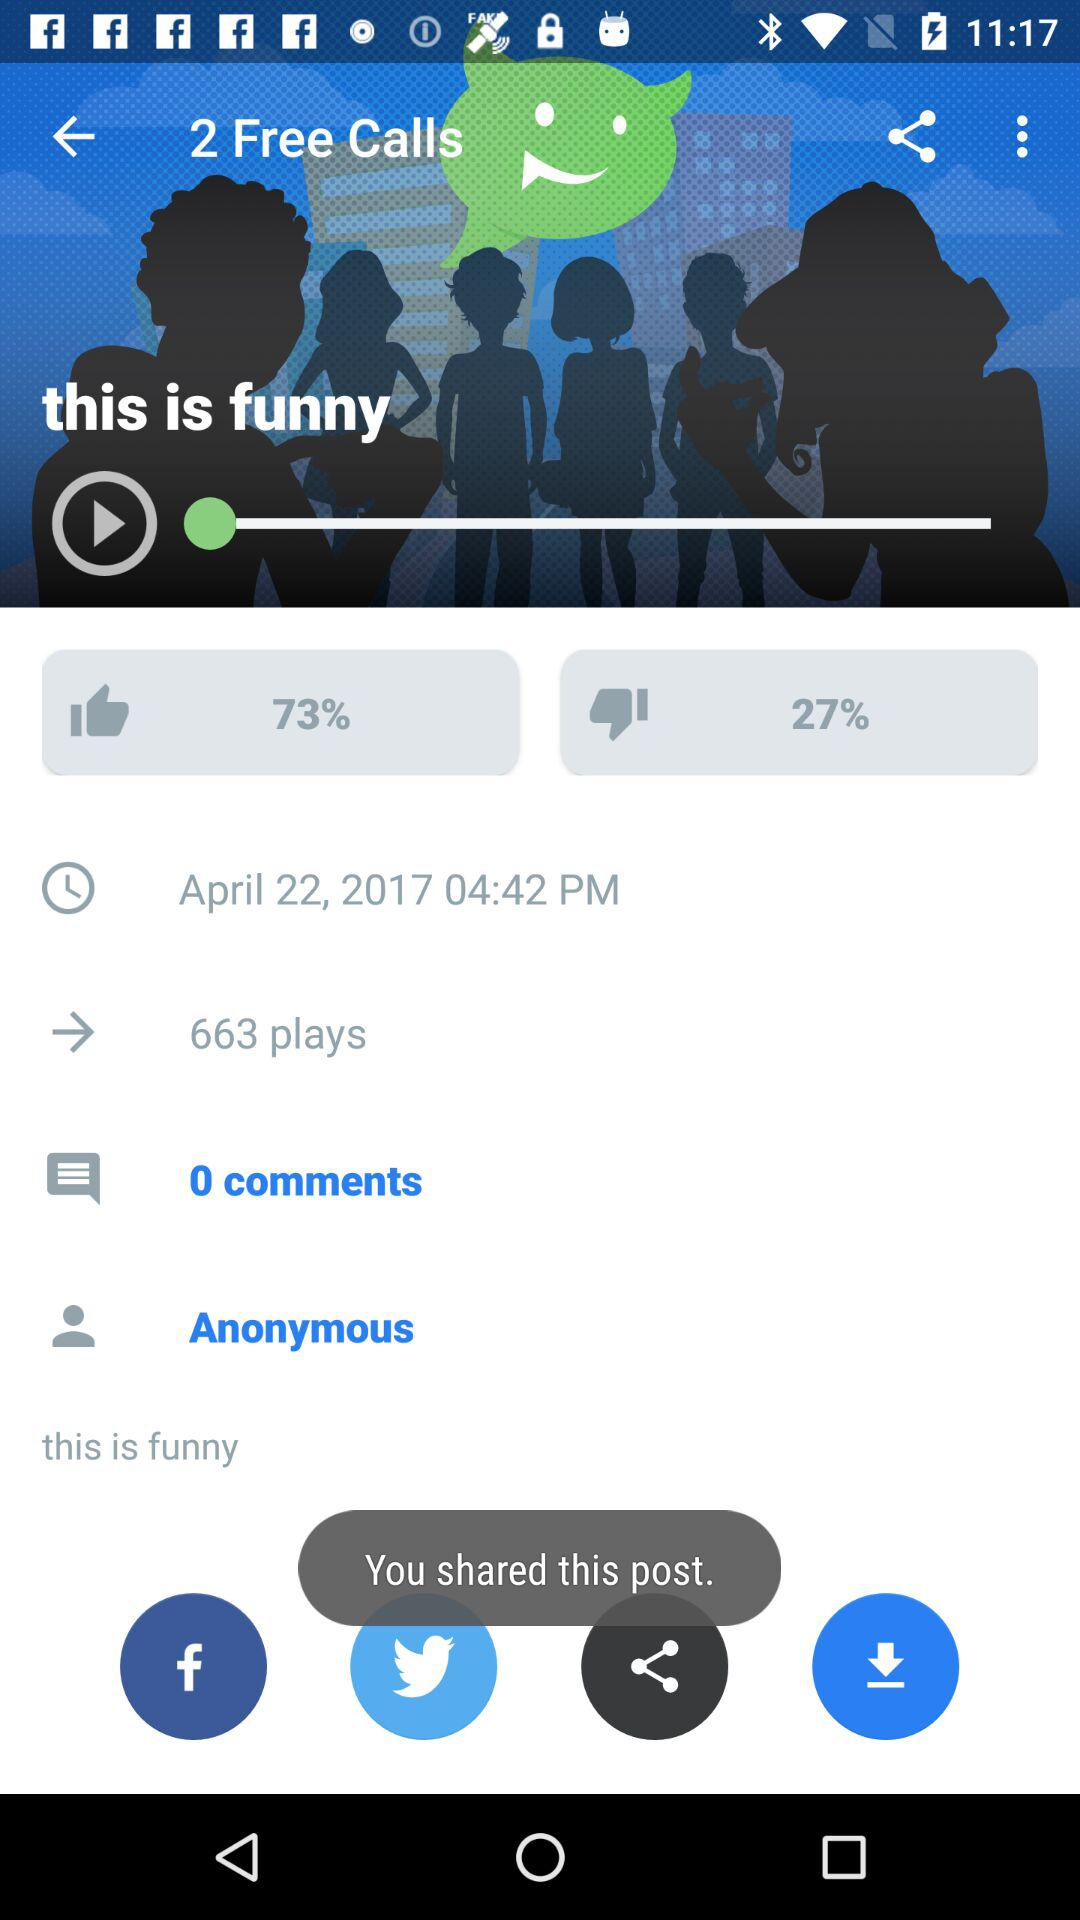What is the date and time? The date and time are April 22, 2017 and 04:42 PM respectively. 